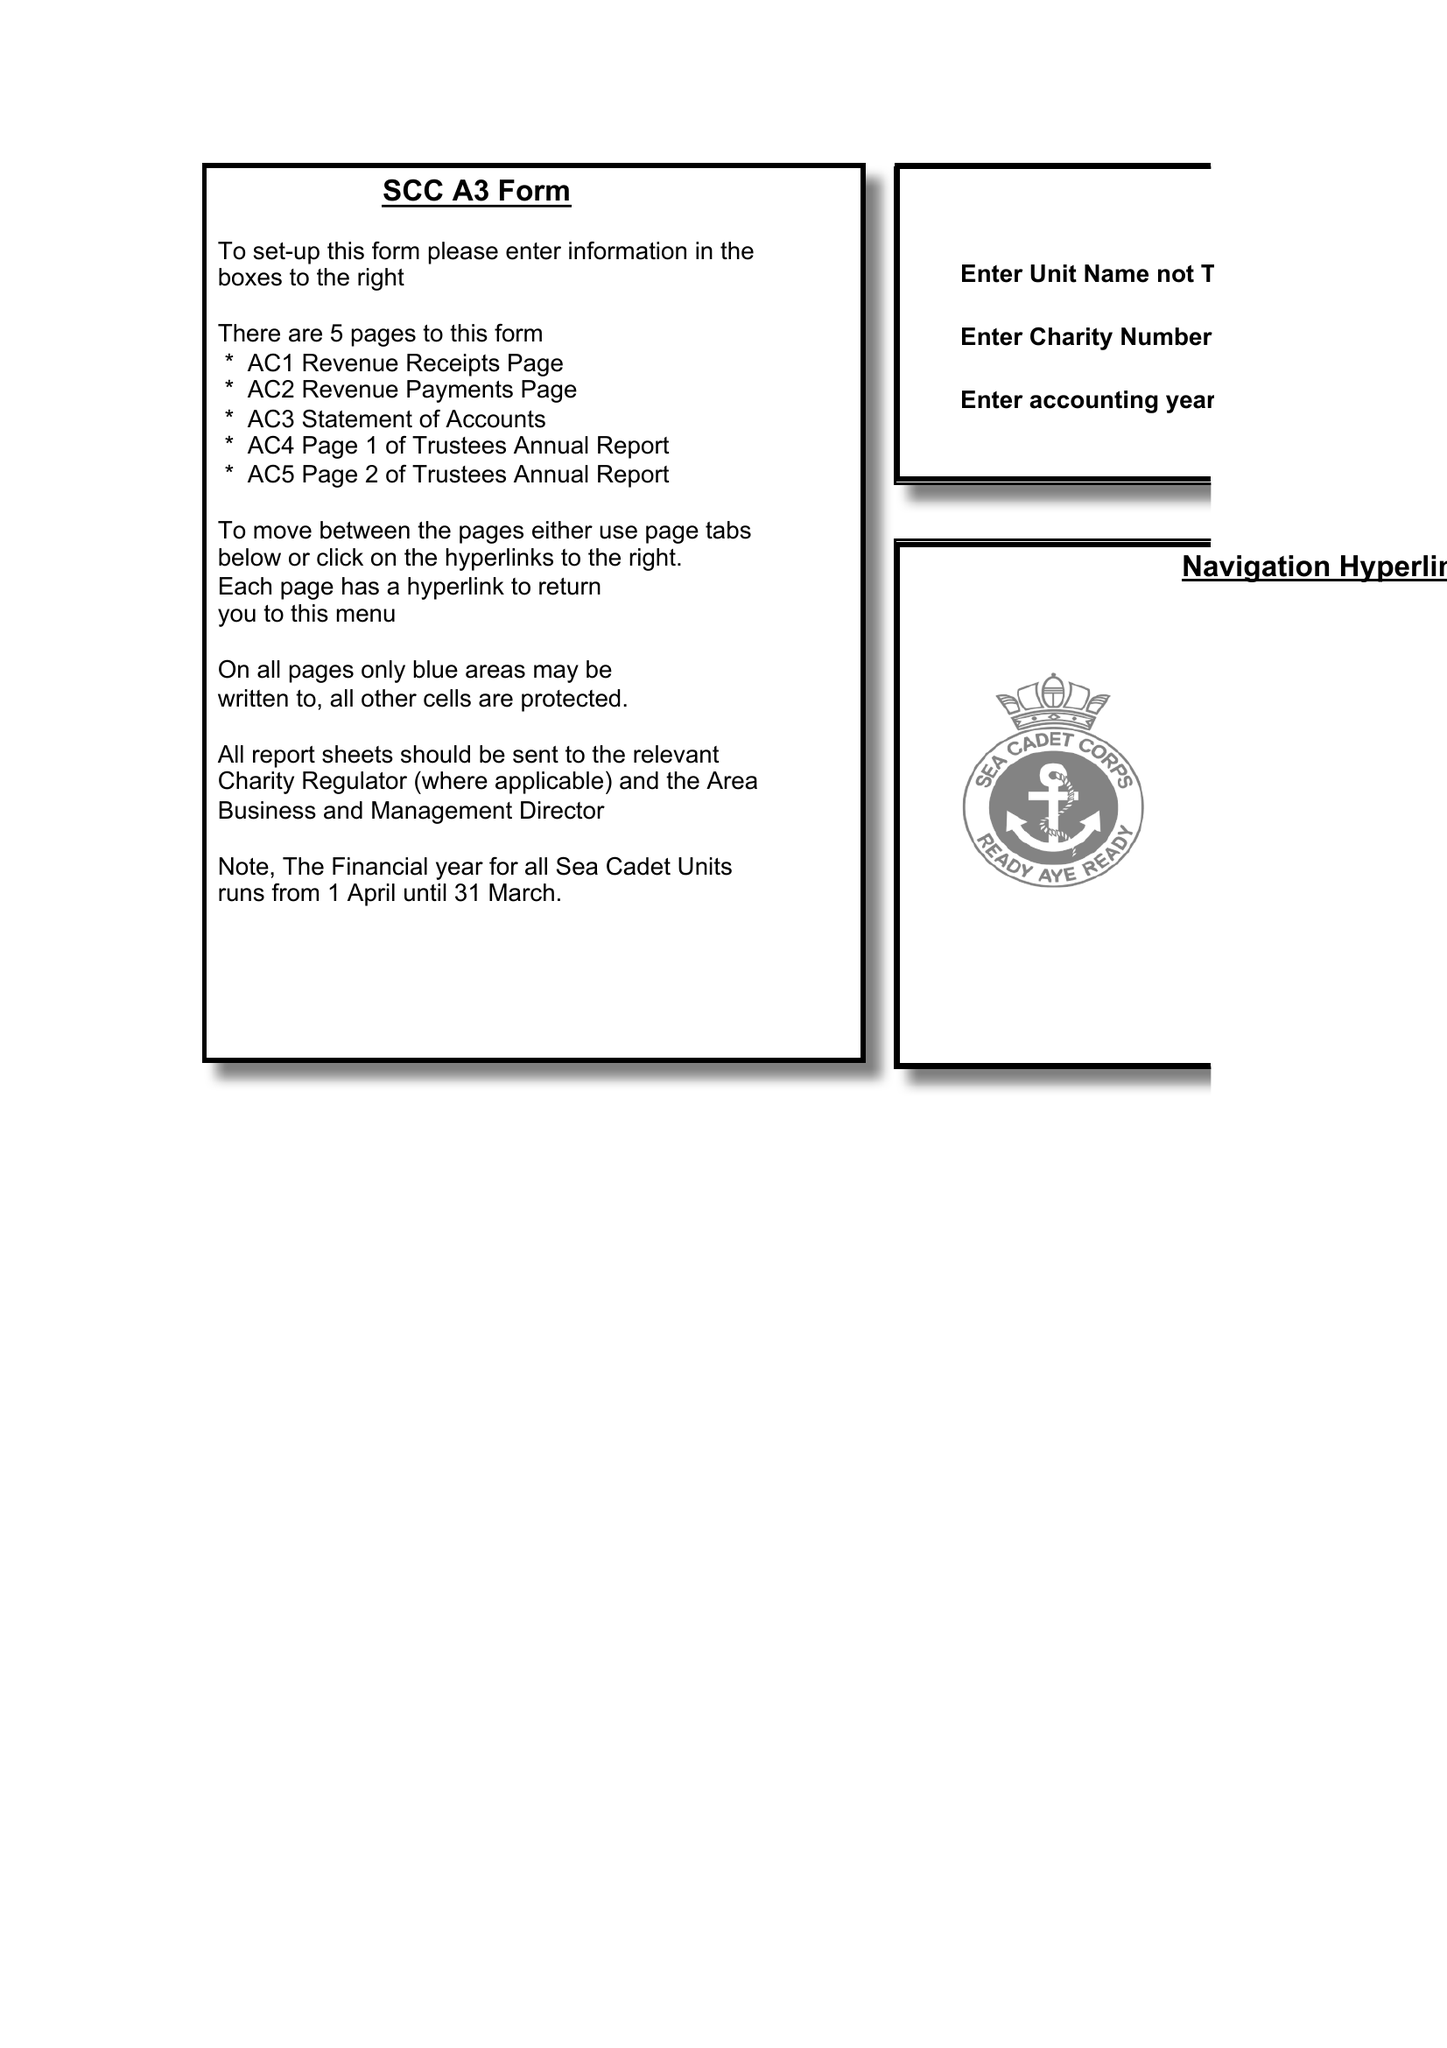What is the value for the report_date?
Answer the question using a single word or phrase. 2017-03-31 